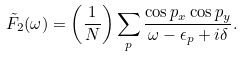Convert formula to latex. <formula><loc_0><loc_0><loc_500><loc_500>\tilde { F } _ { 2 } ( \omega ) = \left ( \frac { 1 } { N } \right ) \sum _ { p } \frac { \cos p _ { x } \cos p _ { y } } { \omega - \epsilon _ { p } + i \delta } .</formula> 